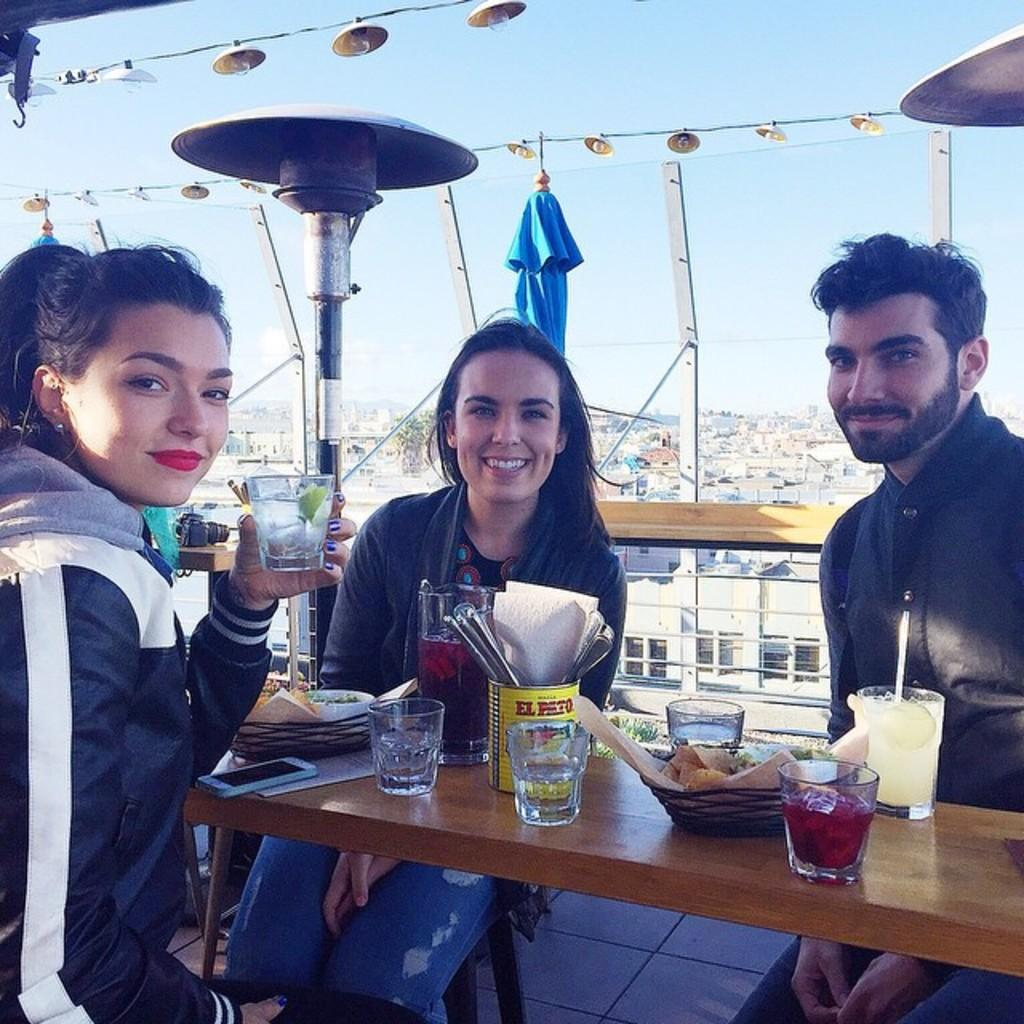How many people are in the image? There are three people in the image. What are the people doing in the image? The people are sitting on chairs. What is in front of the people? There is a table in front of the people. What is on the table? There are mocktails on the table. What is the mood of the people in the image? The people are smiling, which suggests a positive mood. What type of church is visible in the background of the image? There is no church visible in the background of the image. What suggestion is being made by the people in the image? The image does not depict any suggestions being made by the people; they are simply sitting and smiling. 